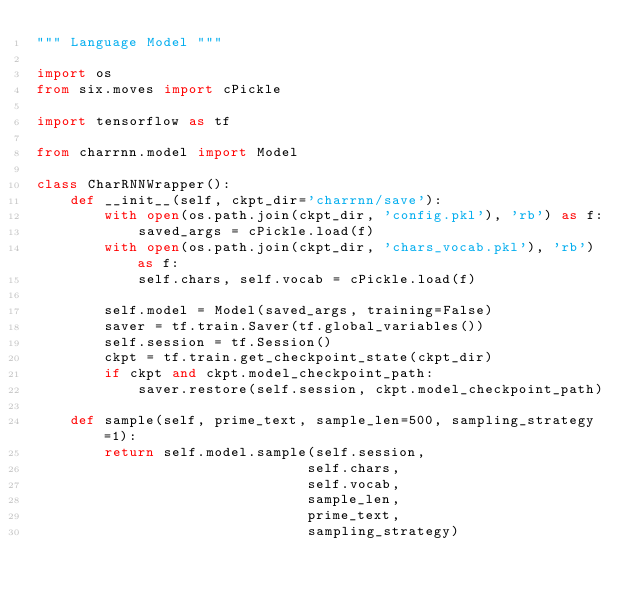<code> <loc_0><loc_0><loc_500><loc_500><_Python_>""" Language Model """

import os
from six.moves import cPickle

import tensorflow as tf

from charrnn.model import Model

class CharRNNWrapper():
    def __init__(self, ckpt_dir='charrnn/save'):
        with open(os.path.join(ckpt_dir, 'config.pkl'), 'rb') as f:
            saved_args = cPickle.load(f)
        with open(os.path.join(ckpt_dir, 'chars_vocab.pkl'), 'rb') as f:
            self.chars, self.vocab = cPickle.load(f)
        
        self.model = Model(saved_args, training=False)
        saver = tf.train.Saver(tf.global_variables())
        self.session = tf.Session()
        ckpt = tf.train.get_checkpoint_state(ckpt_dir)
        if ckpt and ckpt.model_checkpoint_path:
            saver.restore(self.session, ckpt.model_checkpoint_path)

    def sample(self, prime_text, sample_len=500, sampling_strategy=1):
        return self.model.sample(self.session,
                                self.chars,
                                self.vocab,
                                sample_len,
                                prime_text,
                                sampling_strategy)</code> 